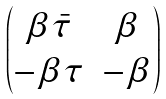<formula> <loc_0><loc_0><loc_500><loc_500>\begin{pmatrix} \beta \bar { \tau } & \beta \\ - \beta \tau & - \beta \end{pmatrix}</formula> 